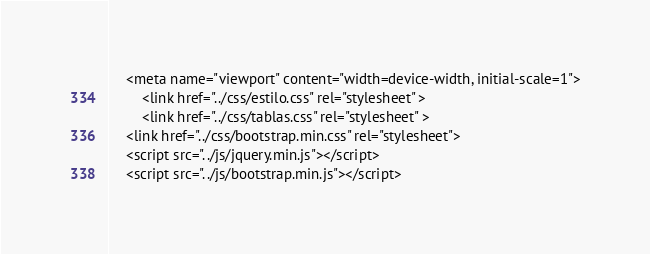<code> <loc_0><loc_0><loc_500><loc_500><_PHP_>	<meta name="viewport" content="width=device-width, initial-scale=1">
        <link href="../css/estilo.css" rel="stylesheet" >
        <link href="../css/tablas.css" rel="stylesheet" >
  	<link href="../css/bootstrap.min.css" rel="stylesheet">
  	<script src="../js/jquery.min.js"></script>
  	<script src="../js/bootstrap.min.js"></script></code> 